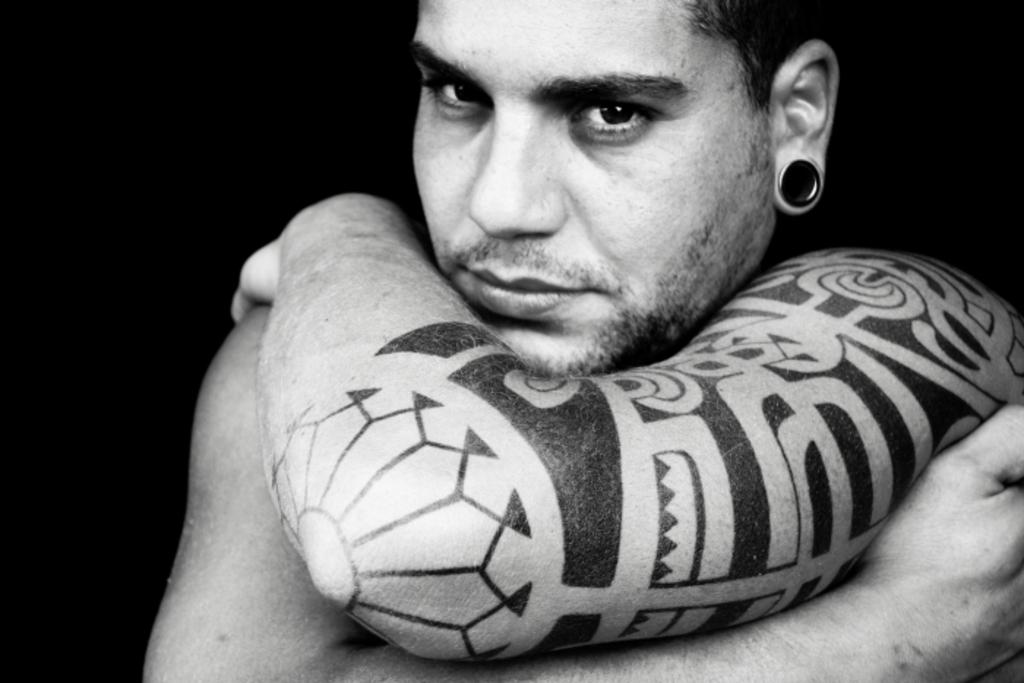What is present in the image? There is a person in the image. Can you describe any distinguishing features of the person? The person has a tattoo on their hand. What type of meal is being prepared by the pigs in the image? There are no pigs or meal preparation present in the image; it only features a person with a tattoo on their hand. 